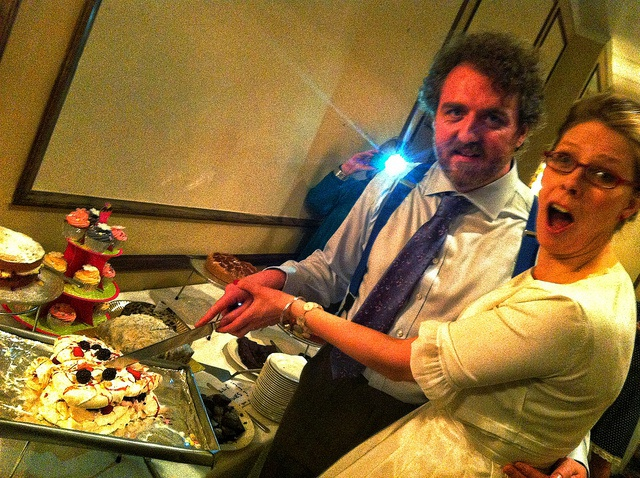Describe the objects in this image and their specific colors. I can see people in maroon, olive, and gold tones, people in maroon, black, khaki, and gray tones, cake in maroon, khaki, lightyellow, and orange tones, tie in maroon, black, and purple tones, and people in maroon, black, navy, and gray tones in this image. 